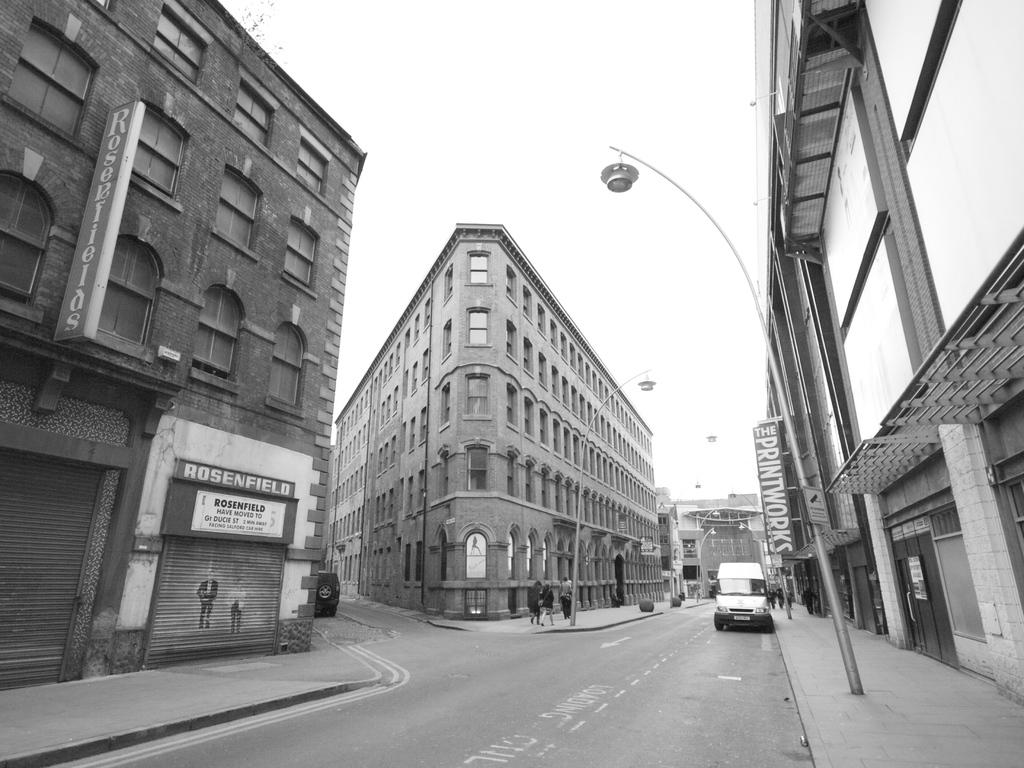<image>
Offer a succinct explanation of the picture presented. A black and white downtown scene with The Printworks sign above a sidewalk 